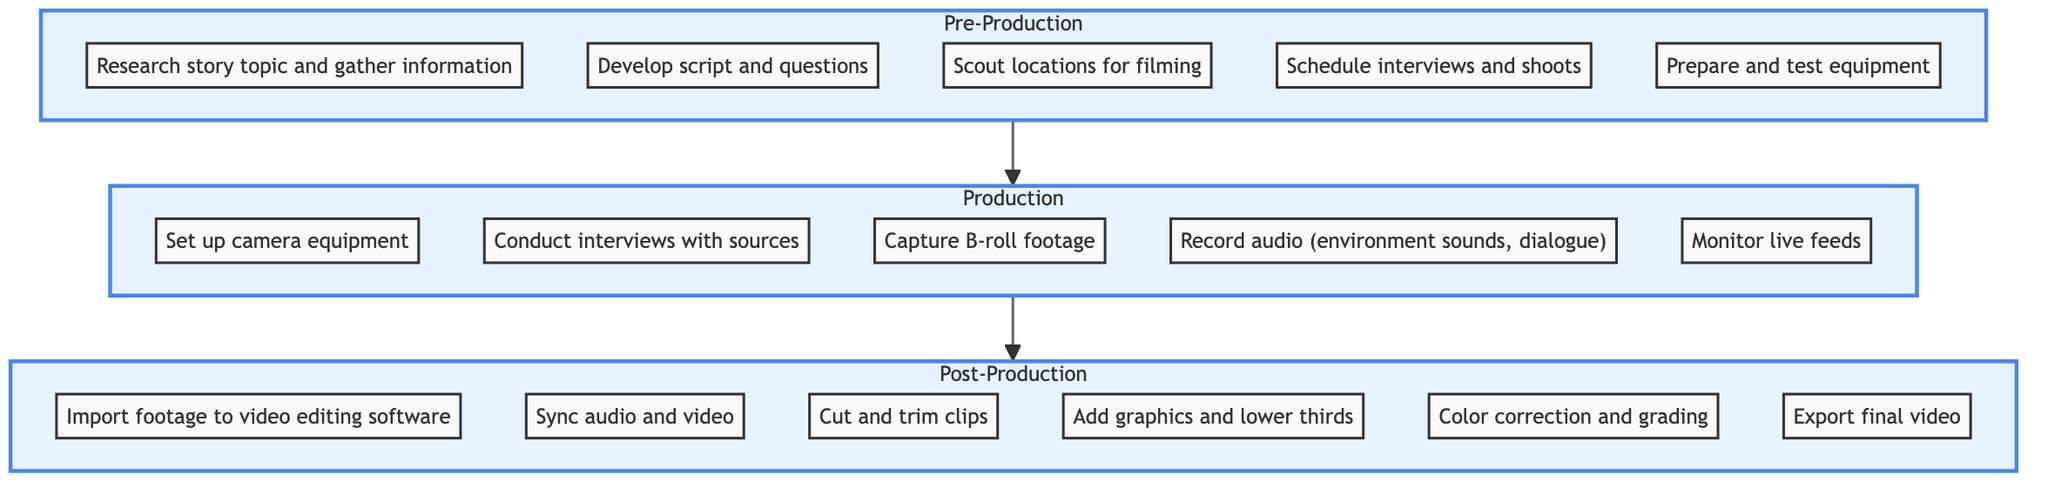What is the final stage in the video production breakdown? The diagram indicates that the last stage before the project is completed is Post-Production.
Answer: Post-Production How many tasks are in the Production stage? By counting the listed tasks within the Production section, we find there are five tasks: set up camera equipment, conduct interviews with sources, capture B-roll footage, record audio, and monitor live feeds.
Answer: 5 Which stage comes immediately before Post-Production? The flowchart shows that Production flows into Post-Production, indicating that Production is the stage that comes right before Post-Production.
Answer: Production How many tasks are listed in the Pre-Production stage? The Pre-Production section includes five tasks: research story topic, develop script, scout locations, schedule interviews, and prepare equipment. Counting these gives us five tasks in total.
Answer: 5 What task occurs first in Post-Production? Looking at the order of tasks within the Post-Production section, the first task listed is to import footage to video editing software.
Answer: Import footage to video editing software Which stage involves interviewing sources? The task of conducting interviews with sources is specifically listed under the Production stage. Thus, this activity is part of the Production stage.
Answer: Production What is the second task in the Pre-Production stage? The tasks in the Pre-Production stage are listed in sequence, with the second task being to develop the script and questions after researching the story topic.
Answer: Develop script and questions In which stage would you schedule interviews? Scheduling interviews, as indicated in the Pre-Production section, is a preliminary task that prepares for the production of the news story.
Answer: Pre-Production What is the total number of tasks across all stages? By adding the tasks: Post-Production (6) + Production (5) + Pre-Production (5), the total tasks amount to 16.
Answer: 16 